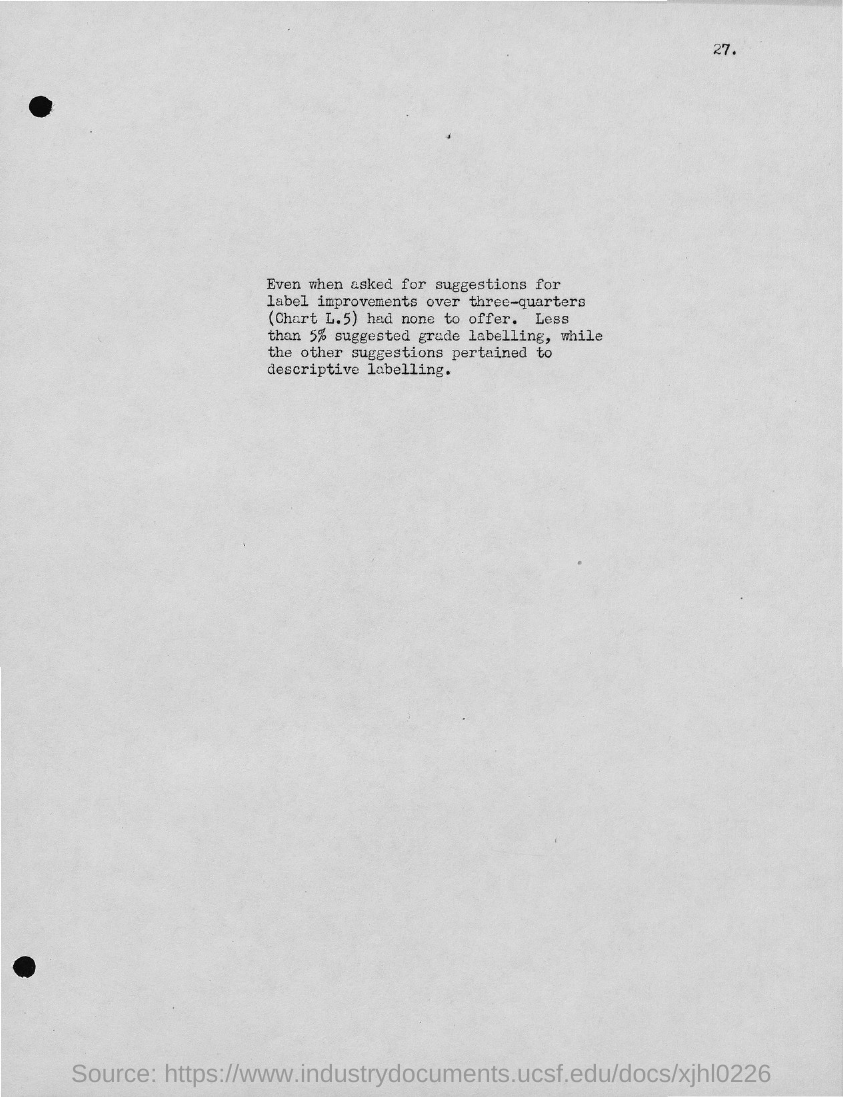Draw attention to some important aspects in this diagram. DESCRIPTIVE LABELLING was pertained, except for GRADE LABELLING. 